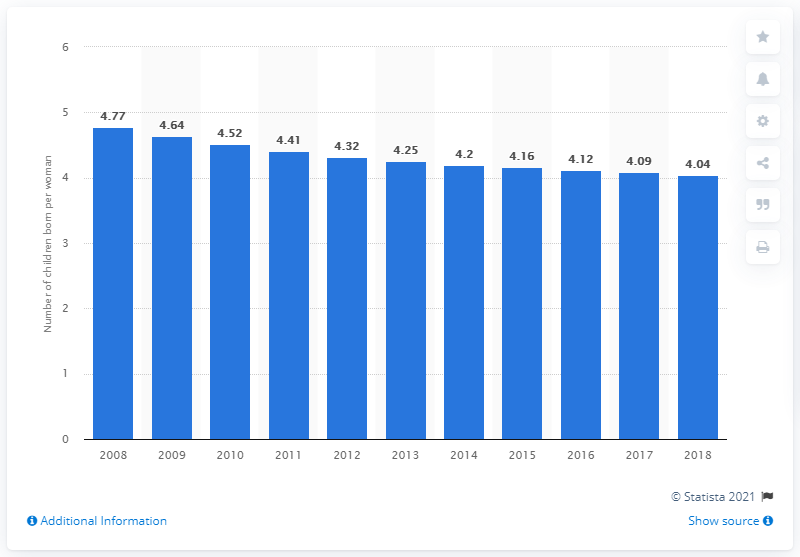Point out several critical features in this image. The fertility rate in Rwanda in 2018 was 4.04. 